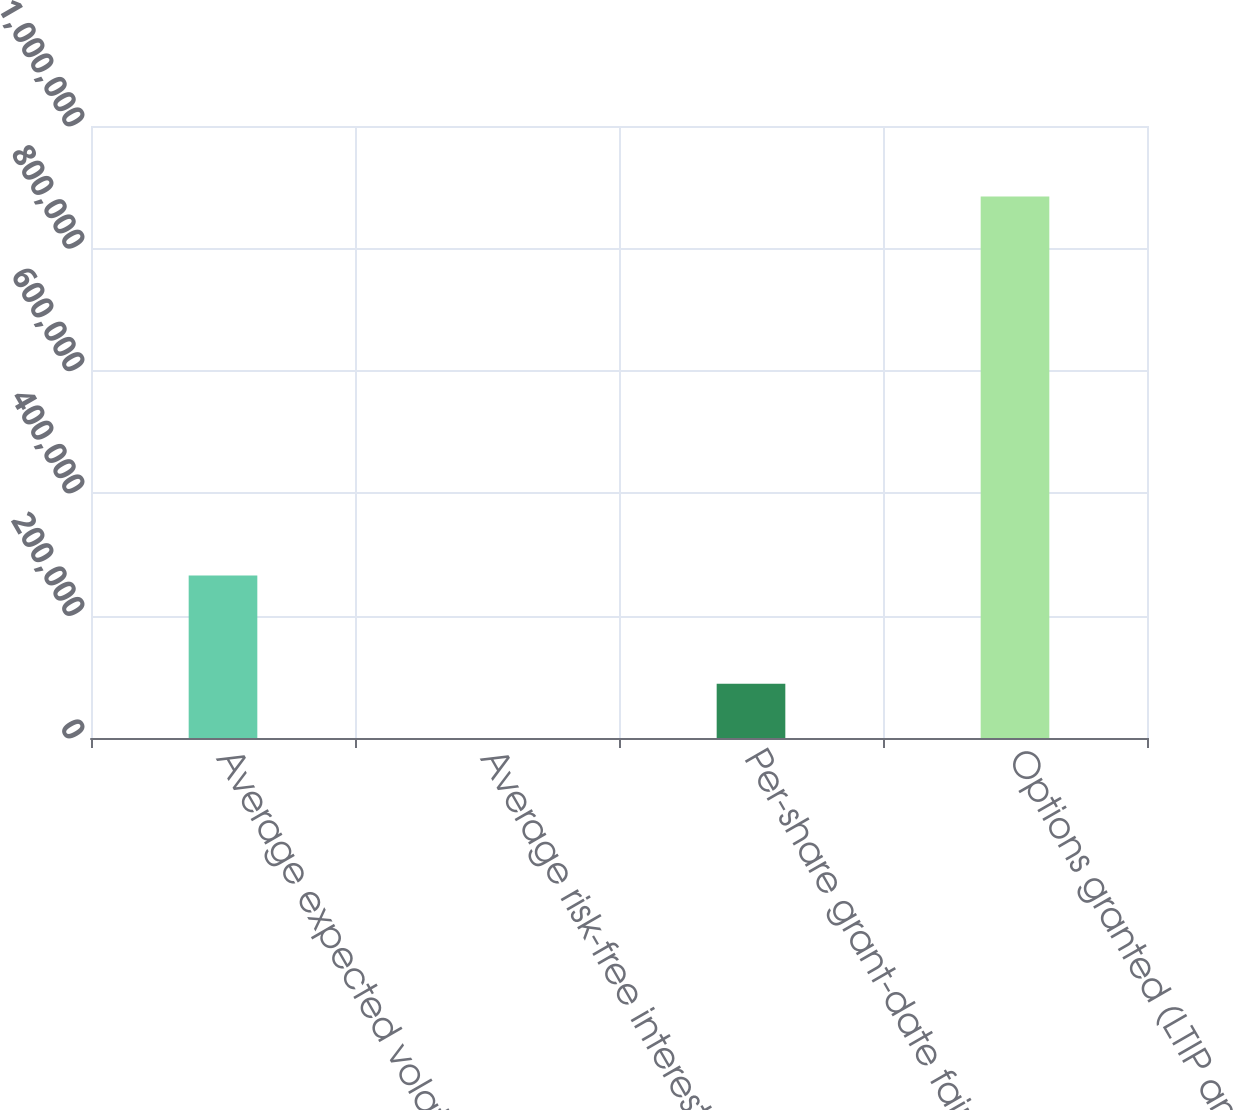Convert chart to OTSL. <chart><loc_0><loc_0><loc_500><loc_500><bar_chart><fcel>Average expected volatility<fcel>Average risk-free interest<fcel>Per-share grant-date fair<fcel>Options granted (LTIP and<nl><fcel>265412<fcel>3.42<fcel>88473.1<fcel>884700<nl></chart> 